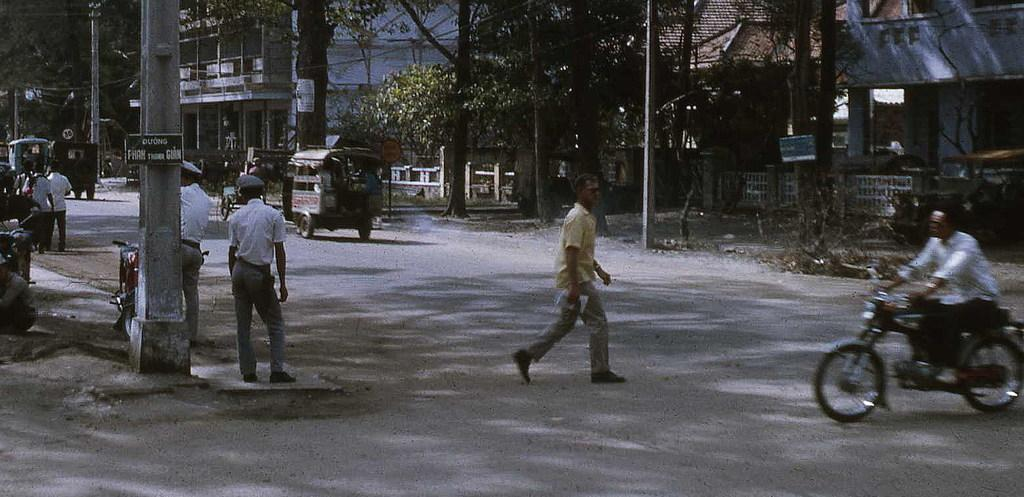What type of structures can be seen in the image? There are houses in the image. What other natural elements are present in the image? There are trees in the image. Are there any living beings visible in the image? Yes, there are people in the image. What vehicles can be seen in the image? There is a motorcycle and a jeep in the image. How many beds can be seen in the image? There are no beds present in the image. What type of lizard is sitting on the jeep in the image? There are no lizards present in the image. 